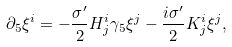Convert formula to latex. <formula><loc_0><loc_0><loc_500><loc_500>\partial _ { 5 } \xi ^ { i } = - \frac { \sigma ^ { \prime } } { 2 } H _ { j } ^ { i } \gamma _ { 5 } \xi ^ { j } - \frac { i \sigma ^ { \prime } } { 2 } K _ { j } ^ { i } \xi ^ { j } ,</formula> 